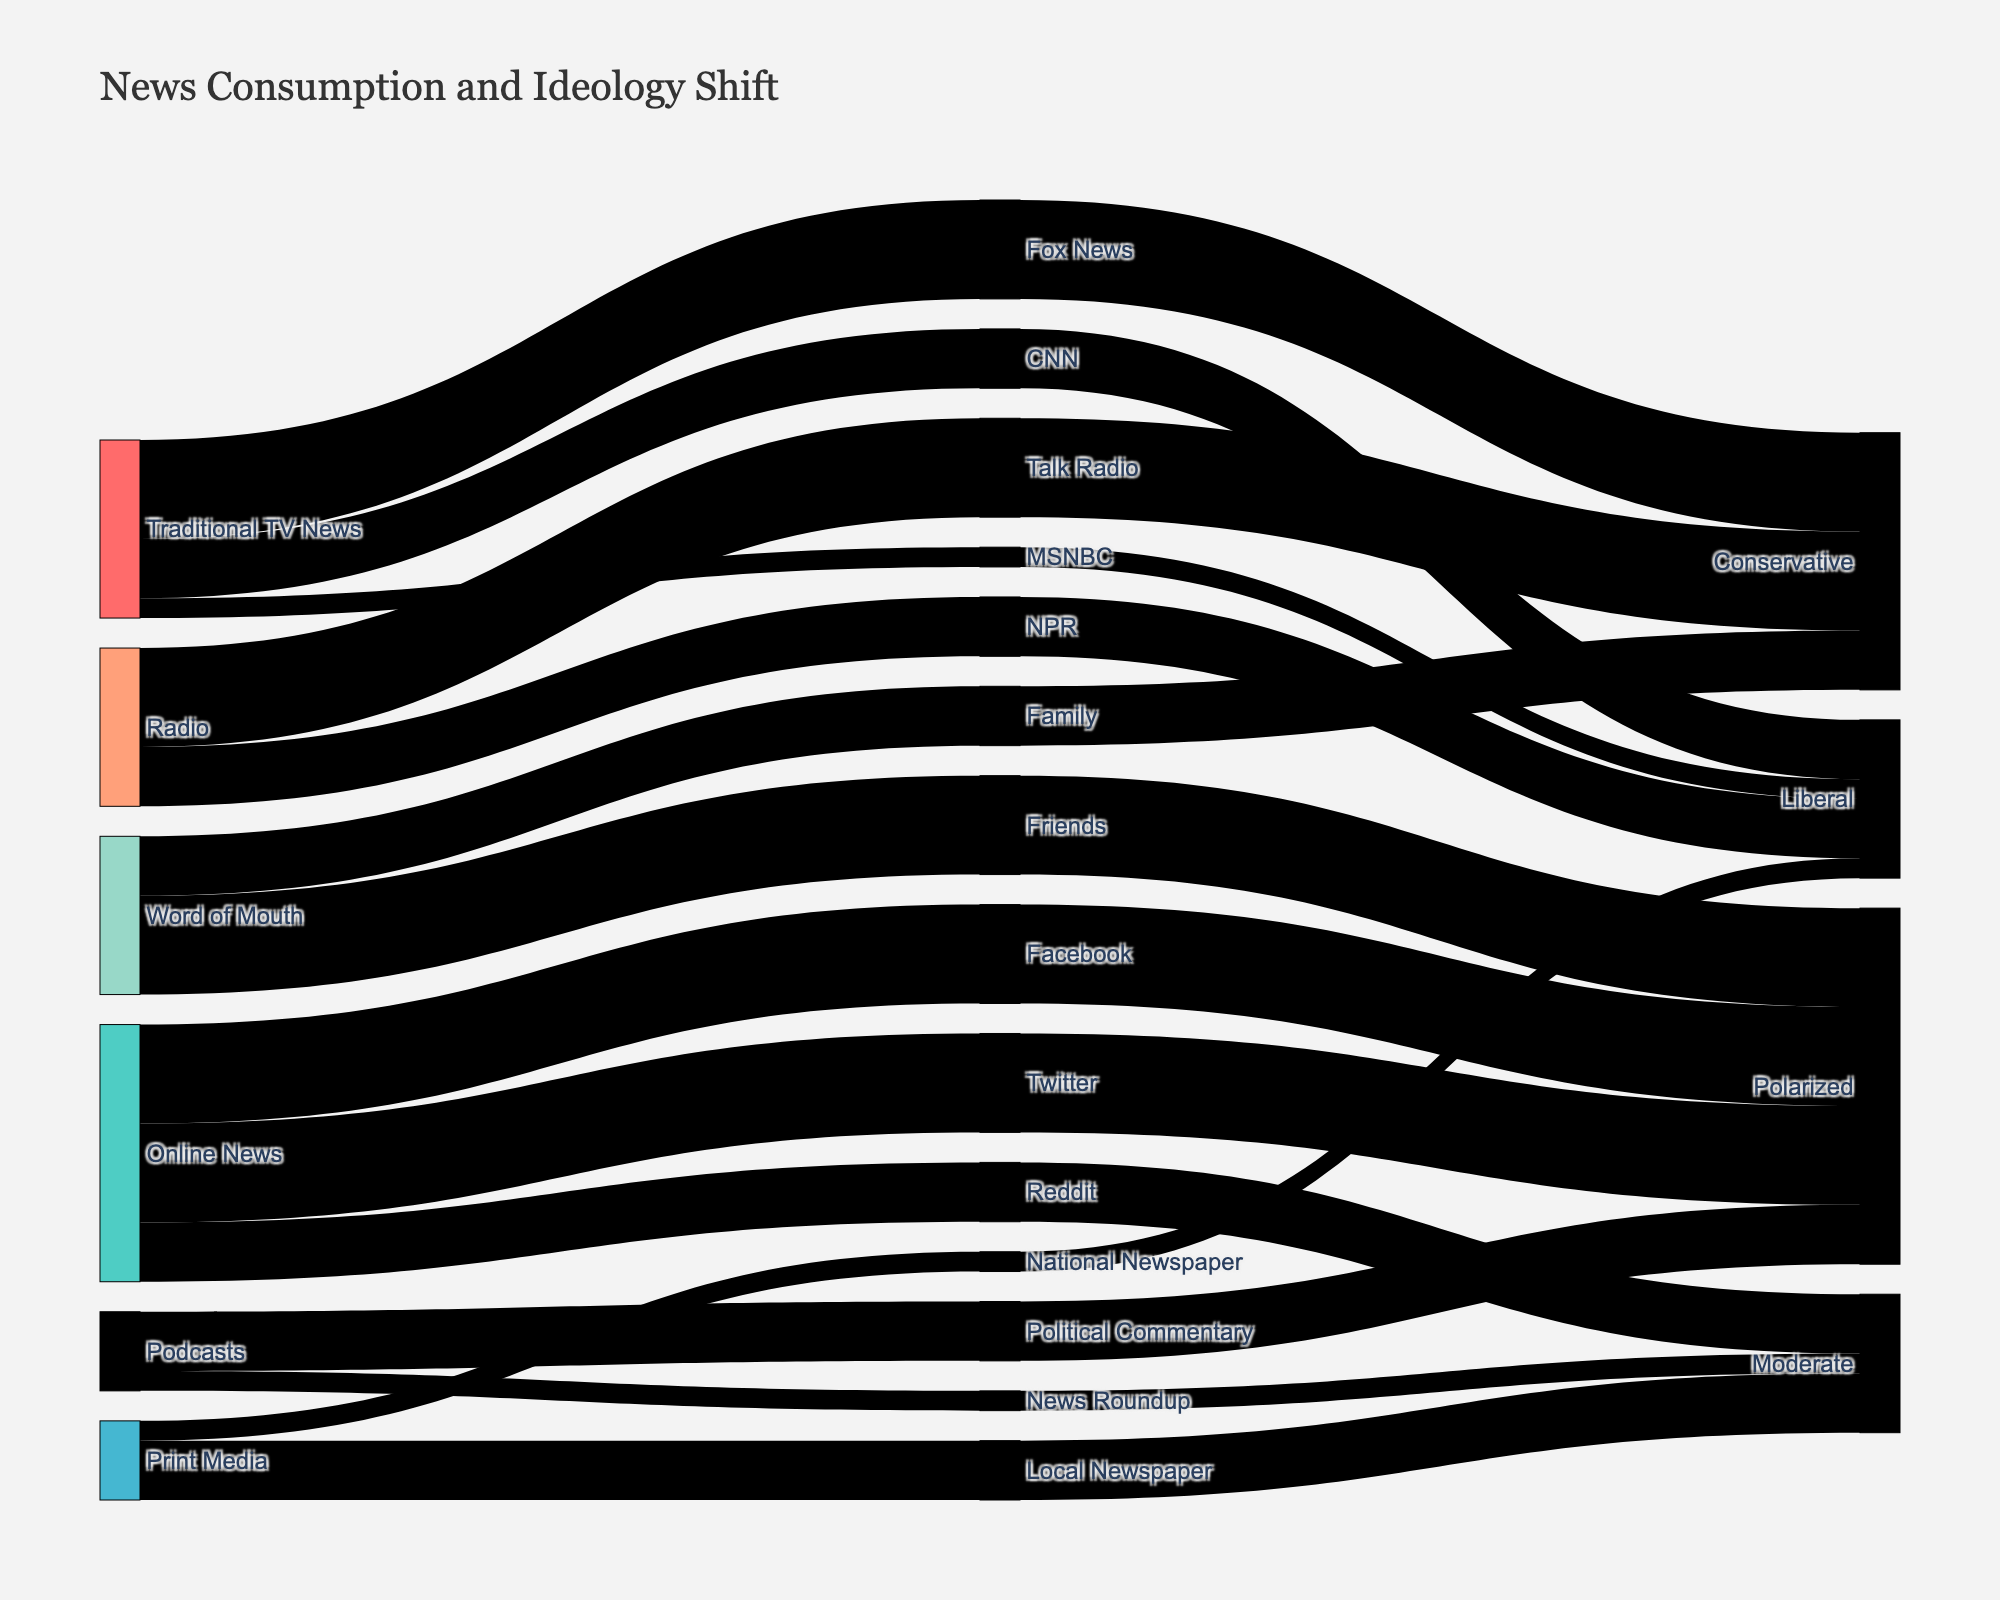What is the title of the Sankey diagram? The title of a figure is usually displayed at the top and provides a brief summary of what the figure represents. In this case, the title says "News Consumption and Ideology Shift."
Answer: News Consumption and Ideology Shift Which news source has a daily frequency and contributes to a conservative ideology shift? To find this, look at the links starting from 'source' and follow the nodes to 'medium' and then to 'ideology_shift.' The only source with a daily frequency contributing to a conservative ideology shift is 'Traditional TV News' connecting through 'Fox News.'
Answer: Traditional TV News How are 'Online News' sources contributing to political ideology shifts? Check the nodes and links starting from 'Online News', then look at the resulting ideology shifts. Online News sources lead to 'Facebook,' 'Twitter,' and 'Reddit,' resulting in polarized and moderate shifts.
Answer: Polarized and Moderate Which media has the highest varieties of political ideology shifts and what are they? Look at all the mediums and count their connections to different ideology shifts. The medium with the highest variety is Online News, connected to Polarized and Moderate shifts.
Answer: Online News, Polarized and Moderate In terms of frequency, how does 'Radio' compare to 'Print Media' in contributing to overall political ideology shifts? Compare the frequency values linked from 'Radio' and 'Print Media' to their respective mediums and ideology shifts. Radio has 'Talk Radio' and 'NPR' connecting daily and weekly frequencies to conservative and liberal ideologies, whereas Print Media connects 'Local Newspaper' and 'National Newspaper' weekly and occasionally to moderate and liberal ideologies. Daily frequency in Radio outweighs the occasionally in Print Media.
Answer: Radio has higher daily frequency contributions compared to Print Media's occasional How many 'Weekly' frequency entries contribute to a 'Liberal' ideology shift? Check all the links associated with 'Weekly' frequencies and tally how many of them result in 'Liberal' shifts. They include CNN, NPR, and National Newspaper.
Answer: Three Which source contributes to both 'Moderate' and 'Liberal' ideologies with different mediums? Look for a source connected to different mediums leading to different ideology shifts. 'Print Media' contributes to moderate ideology through 'Local Newspaper' and liberal ideology through 'National Newspaper.'
Answer: Print Media What is the frequency of the 'Friends' medium under the 'Word of Mouth' source and its impact on political ideology? Locate 'Friends' under the 'Word of Mouth' source and note its frequency and resulting ideology shift. The frequency is 'Daily,' leading to a polarized shift.
Answer: Daily, Polarized 